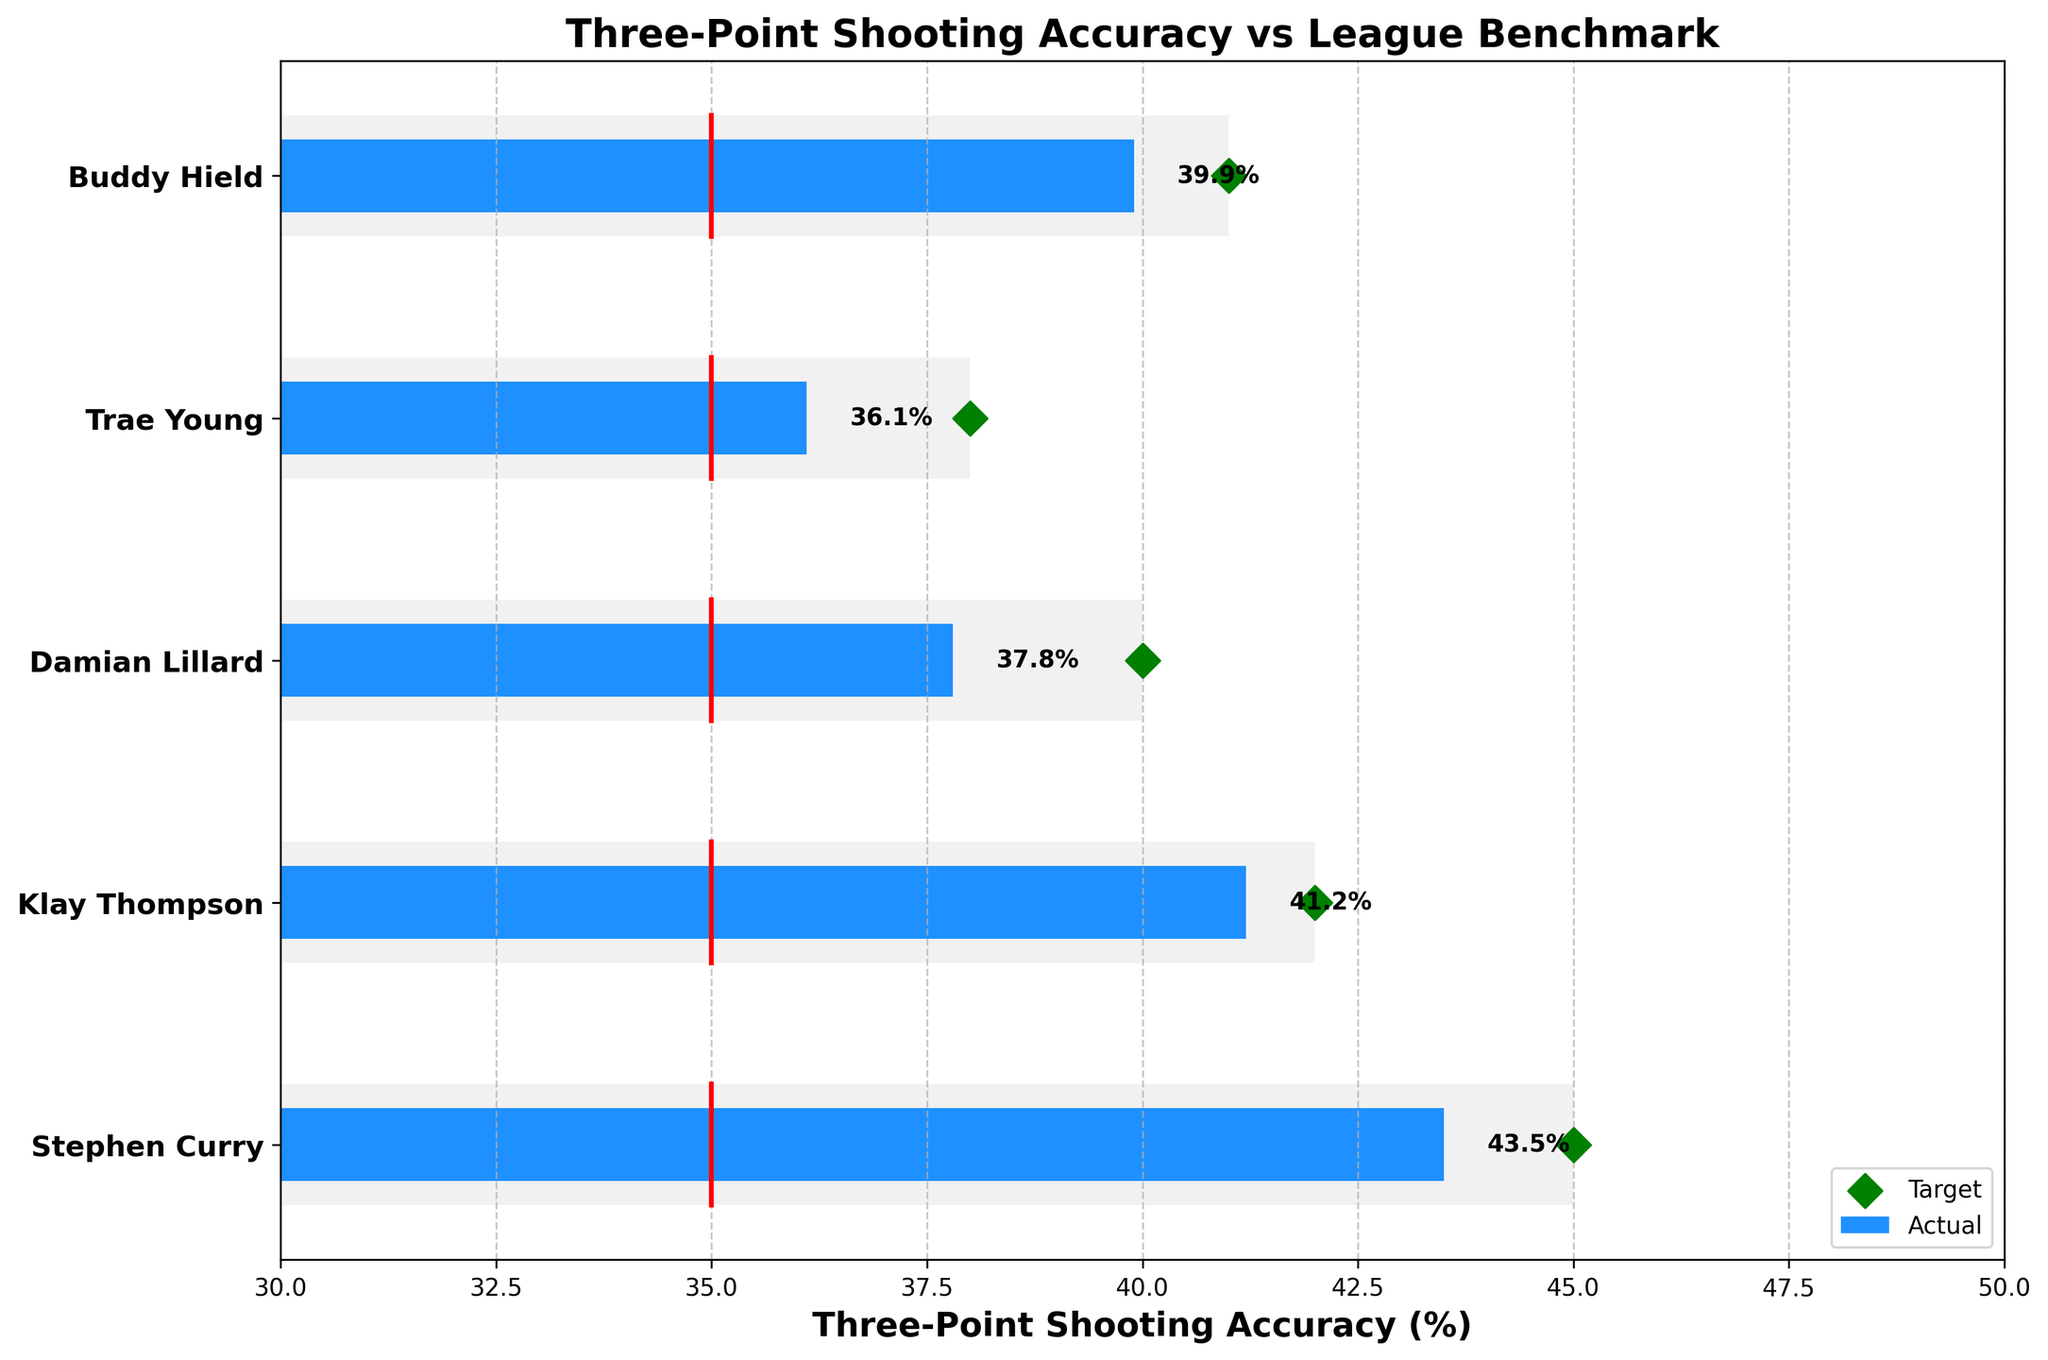What's the title of the plot? The title is situated at the top of the plot and typically summarizes the information being presented.
Answer: Three-Point Shooting Accuracy vs League Benchmark How many players are analyzed in the plot? The y-axis of the plot lists the players' names, allowing us to count the number of players. There are five players listed.
Answer: 5 Which player has the highest actual three-point shooting accuracy? By looking at the lengths of the blue bars representing actual performance, Stephen Curry has the longest bar. His value is confirmed by the label next to the bar indicating 43.5%.
Answer: Stephen Curry What is the benchmark percentage for the league? The benchmark is shown as a red line and indicated in the data table next to 'Benchmark,' which is the same for all players.
Answer: 35.0% Which player is closest to hitting their target? Evaluate the distance between each player's actual performance (blue bar) and their target (green diamond). Klay Thompson has an actual of 41.2 and a target of 42.0, making him closest.
Answer: Klay Thompson What is the average three-point shooting accuracy of all players combined? Sum the actual values and divide by the number of players: (43.5 + 41.2 + 37.8 + 36.1 + 39.9) / 5 = 39.7%.
Answer: 39.7% Which player's actual performance is farthest below their target? Calculate the difference between actual and target for each player: Stephen Curry (43.5-45.0)= -1.5, Klay Thompson (41.2-42.0)= -0.8, Damian Lillard (37.8-40.0)= -2.2, Trae Young (36.1-38.0)= -1.9, Buddy Hield (39.9-41.0)= -1.1. Damian Lillard has the largest negative difference.
Answer: Damian Lillard How does Buddy Hield's actual performance compare to the league benchmark? Buddy Hield's actual performance (39.9%) is higher than the league benchmark (35.0%) since 39.9 > 35.0.
Answer: Higher Which players have exceeded the league benchmark? Compare each player's actual performance to the benchmark. Stephen Curry (43.5), Klay Thompson (41.2), Damian Lillard (37.8), Trae Young (36.1), and Buddy Hield (39.9) all exceed the benchmark of 35.0. Therefore, all players listed exceed it.
Answer: All players By how much does Stephen Curry's actual performance exceed the league benchmark? Stephen Curry's actual performance is 43.5%. Subtract the league benchmark from this value: 43.5 - 35.0 = 8.5%.
Answer: 8.5% 